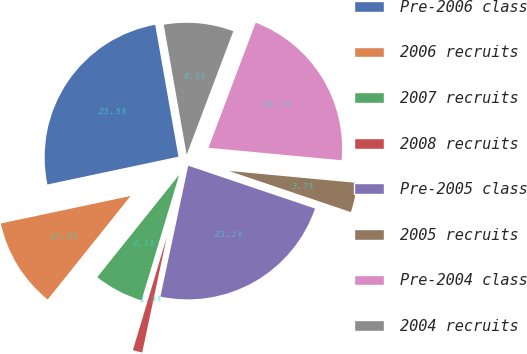Convert chart to OTSL. <chart><loc_0><loc_0><loc_500><loc_500><pie_chart><fcel>Pre-2006 class<fcel>2006 recruits<fcel>2007 recruits<fcel>2008 recruits<fcel>Pre-2005 class<fcel>2005 recruits<fcel>Pre-2004 class<fcel>2004 recruits<nl><fcel>25.55%<fcel>10.93%<fcel>6.11%<fcel>1.3%<fcel>23.15%<fcel>3.7%<fcel>20.74%<fcel>8.52%<nl></chart> 